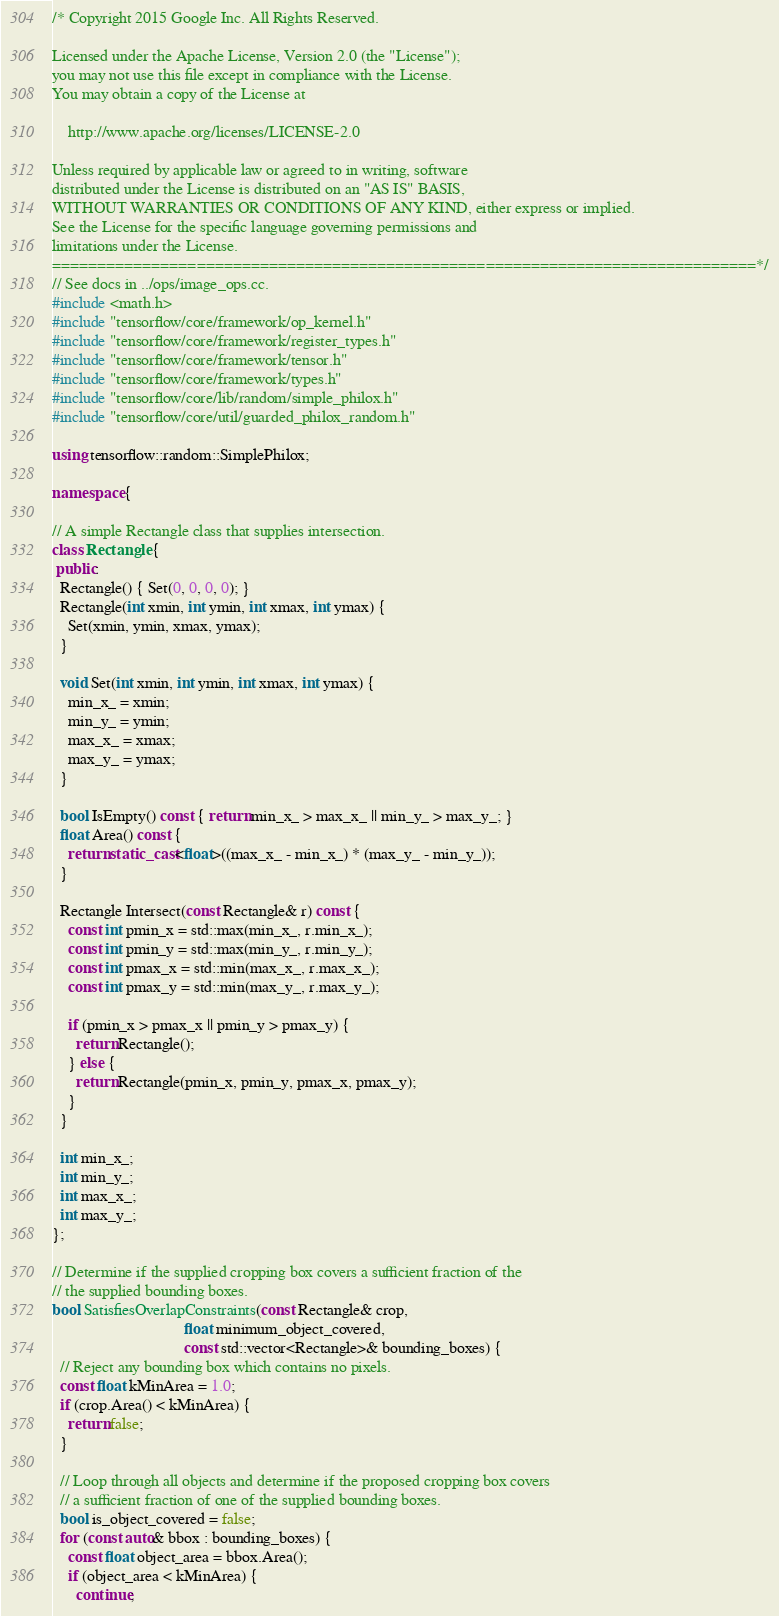Convert code to text. <code><loc_0><loc_0><loc_500><loc_500><_C++_>/* Copyright 2015 Google Inc. All Rights Reserved.

Licensed under the Apache License, Version 2.0 (the "License");
you may not use this file except in compliance with the License.
You may obtain a copy of the License at

    http://www.apache.org/licenses/LICENSE-2.0

Unless required by applicable law or agreed to in writing, software
distributed under the License is distributed on an "AS IS" BASIS,
WITHOUT WARRANTIES OR CONDITIONS OF ANY KIND, either express or implied.
See the License for the specific language governing permissions and
limitations under the License.
==============================================================================*/
// See docs in ../ops/image_ops.cc.
#include <math.h>
#include "tensorflow/core/framework/op_kernel.h"
#include "tensorflow/core/framework/register_types.h"
#include "tensorflow/core/framework/tensor.h"
#include "tensorflow/core/framework/types.h"
#include "tensorflow/core/lib/random/simple_philox.h"
#include "tensorflow/core/util/guarded_philox_random.h"

using tensorflow::random::SimplePhilox;

namespace {

// A simple Rectangle class that supplies intersection.
class Rectangle {
 public:
  Rectangle() { Set(0, 0, 0, 0); }
  Rectangle(int xmin, int ymin, int xmax, int ymax) {
    Set(xmin, ymin, xmax, ymax);
  }

  void Set(int xmin, int ymin, int xmax, int ymax) {
    min_x_ = xmin;
    min_y_ = ymin;
    max_x_ = xmax;
    max_y_ = ymax;
  }

  bool IsEmpty() const { return min_x_ > max_x_ || min_y_ > max_y_; }
  float Area() const {
    return static_cast<float>((max_x_ - min_x_) * (max_y_ - min_y_));
  }

  Rectangle Intersect(const Rectangle& r) const {
    const int pmin_x = std::max(min_x_, r.min_x_);
    const int pmin_y = std::max(min_y_, r.min_y_);
    const int pmax_x = std::min(max_x_, r.max_x_);
    const int pmax_y = std::min(max_y_, r.max_y_);

    if (pmin_x > pmax_x || pmin_y > pmax_y) {
      return Rectangle();
    } else {
      return Rectangle(pmin_x, pmin_y, pmax_x, pmax_y);
    }
  }

  int min_x_;
  int min_y_;
  int max_x_;
  int max_y_;
};

// Determine if the supplied cropping box covers a sufficient fraction of the
// the supplied bounding boxes.
bool SatisfiesOverlapConstraints(const Rectangle& crop,
                                 float minimum_object_covered,
                                 const std::vector<Rectangle>& bounding_boxes) {
  // Reject any bounding box which contains no pixels.
  const float kMinArea = 1.0;
  if (crop.Area() < kMinArea) {
    return false;
  }

  // Loop through all objects and determine if the proposed cropping box covers
  // a sufficient fraction of one of the supplied bounding boxes.
  bool is_object_covered = false;
  for (const auto& bbox : bounding_boxes) {
    const float object_area = bbox.Area();
    if (object_area < kMinArea) {
      continue;</code> 